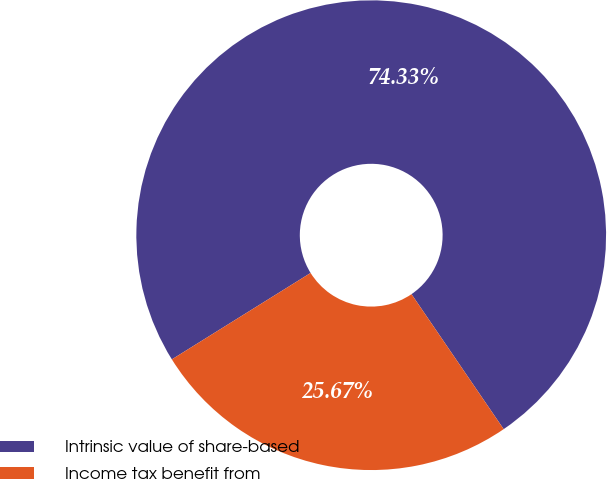<chart> <loc_0><loc_0><loc_500><loc_500><pie_chart><fcel>Intrinsic value of share-based<fcel>Income tax benefit from<nl><fcel>74.33%<fcel>25.67%<nl></chart> 